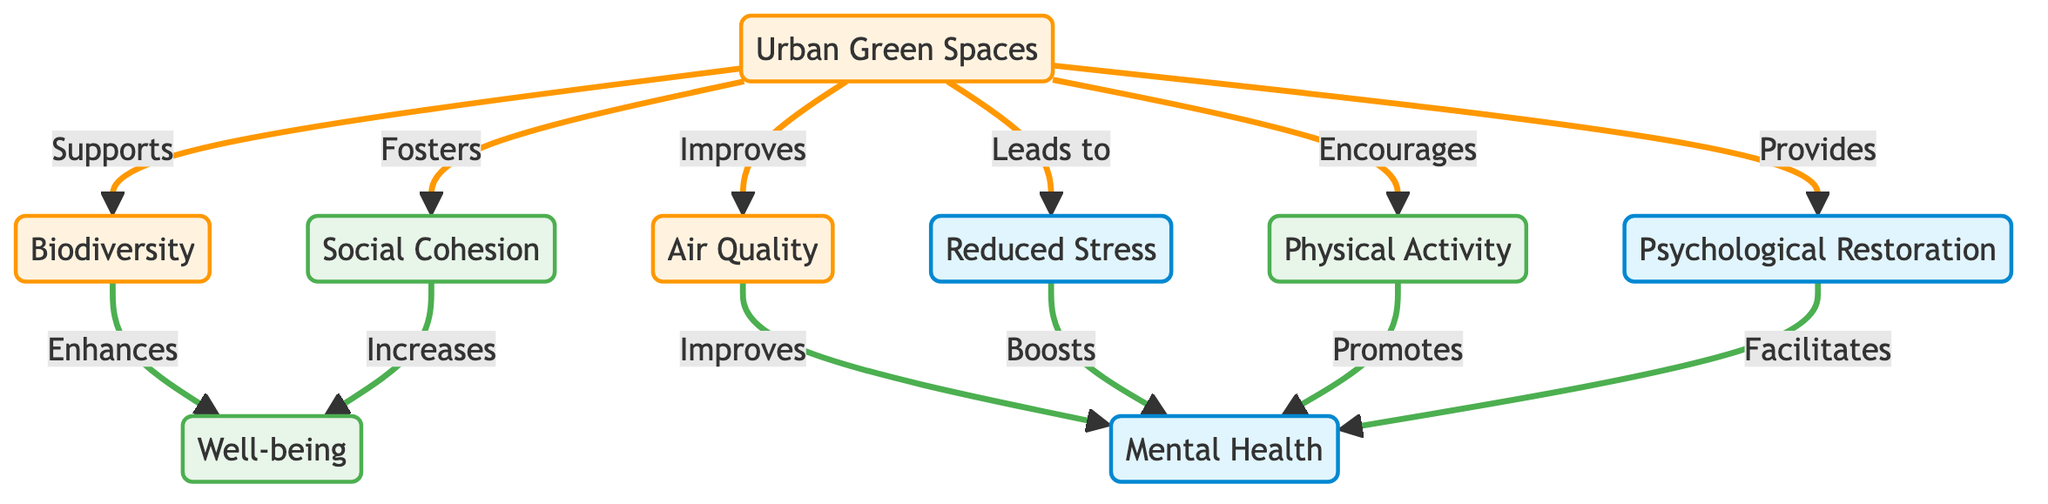What is the main focus of the diagram? The main focus of the diagram is to illustrate the ecosystem services provided by Urban Green Spaces and how they promote Mental Health and Well-being.
Answer: Urban Green Spaces How many connections are shown from Urban Green Spaces? The diagram shows six distinct connections from Urban Green Spaces leading to other nodes. Each connection represents a different service provided.
Answer: 6 What service does Urban Green Spaces provide that leads to Reduced Stress? Urban Green Spaces directly leads to Reduced Stress by fostering a calming environment that can alleviate stress levels in individuals.
Answer: Leads to Which aspect does Biodiversity enhance? Biodiversity enhances Well-being by contributing to a healthy ecosystem that supports various life forms, thereby improving the quality of life for the community.
Answer: Well-being What is the relationship between Air Quality and Mental Health? The relationship is that improved Air Quality directly influences and improves Mental Health, as cleaner air contributes to better physical and psychological conditions.
Answer: Improves How does Social Cohesion affect Well-being? Social Cohesion increases Well-being by promoting a sense of community, togetherness, and support among individuals, which is crucial for overall happiness and satisfaction.
Answer: Increases Which service facilitates Psychological Restoration? Psychological Restoration is facilitated by Urban Green Spaces, which offer spaces for relaxation and mental refreshing activities.
Answer: Provides What type of diagram is this? This diagram is a Natural Science Diagram focused on visualizing ecosystem services and their effects on human health and well-being.
Answer: Natural Science Diagram Which service from Urban Green Spaces is associated with Physical Activity? Physical Activity is encouraged by Urban Green Spaces, providing areas for exercise and recreational activities that promote health and fitness.
Answer: Encourages How many nodes are directly related to Mental Health? There are four nodes directly related to Mental Health in the diagram: Air Quality, Reduced Stress, Physical Activity, and Psychological Restoration.
Answer: 4 